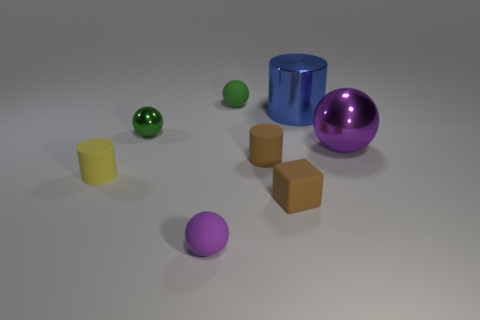Is the color of the tiny matte cylinder that is on the right side of the tiny green matte thing the same as the tiny cube in front of the purple metallic thing?
Offer a very short reply. Yes. Is the size of the matte ball that is to the right of the purple matte object the same as the blue metallic cylinder?
Make the answer very short. No. The purple sphere that is the same material as the big blue cylinder is what size?
Ensure brevity in your answer.  Large. How many other shiny objects have the same shape as the yellow object?
Keep it short and to the point. 1. There is a purple ball that is the same size as the green metallic sphere; what material is it?
Ensure brevity in your answer.  Rubber. Is there a sphere made of the same material as the tiny brown cube?
Offer a terse response. Yes. There is a cylinder that is right of the green metal sphere and in front of the large sphere; what color is it?
Provide a short and direct response. Brown. How many other objects are there of the same color as the tiny metal ball?
Offer a very short reply. 1. What is the material of the tiny brown object that is in front of the small rubber cylinder that is behind the object that is left of the small shiny sphere?
Keep it short and to the point. Rubber. How many spheres are small green metal things or blue objects?
Offer a very short reply. 1. 